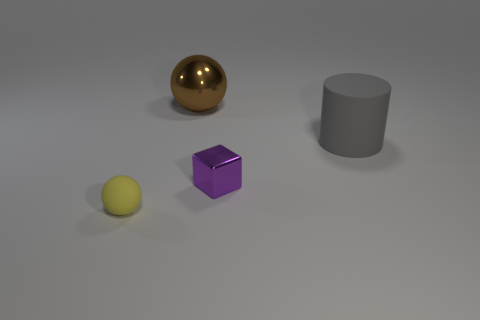Are there any other things that are the same shape as the small metal thing?
Your answer should be very brief. No. There is a cylinder that is the same size as the metallic ball; what color is it?
Make the answer very short. Gray. Is there a metal object of the same shape as the tiny matte object?
Ensure brevity in your answer.  Yes. Are there fewer large metal spheres than small purple balls?
Offer a very short reply. No. The small object that is in front of the tiny purple cube is what color?
Your answer should be very brief. Yellow. The matte object on the left side of the sphere behind the tiny yellow rubber thing is what shape?
Offer a very short reply. Sphere. Is the material of the tiny purple thing the same as the ball to the left of the large metal sphere?
Your answer should be compact. No. How many other brown metal objects have the same size as the brown thing?
Offer a terse response. 0. Is the number of matte things that are in front of the big rubber cylinder less than the number of cubes?
Keep it short and to the point. No. What number of big shiny balls are to the right of the small purple metal thing?
Provide a succinct answer. 0. 